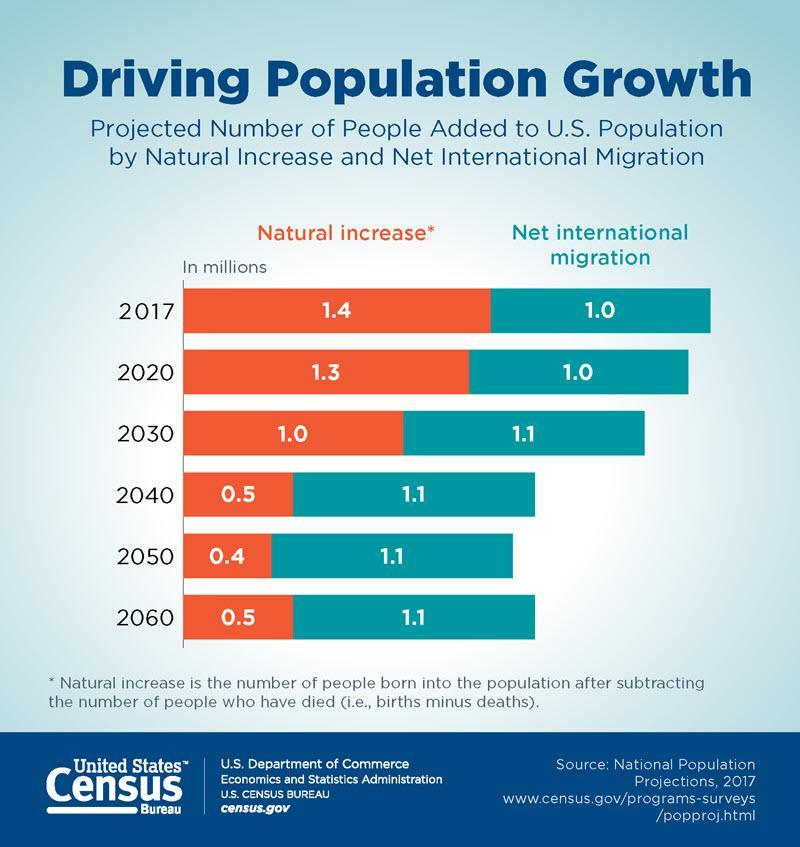How many years have net international migration as 1.1?
Answer the question with a short phrase. 4 What is the net international migration in 2020 and 2030, taken together? 2.1 How many years have net international migration as 1.0? 2 